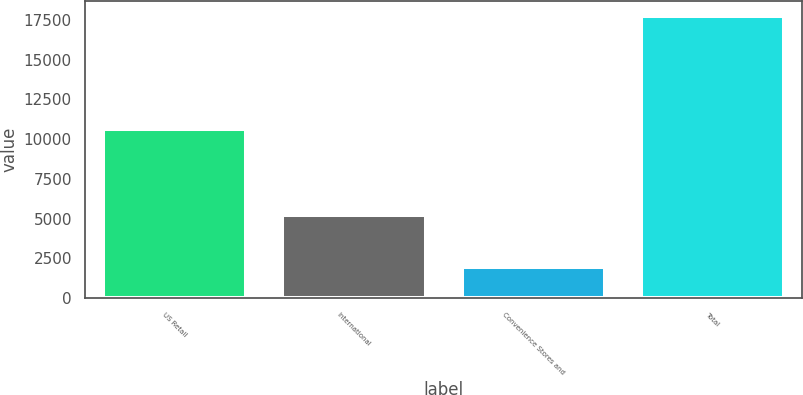Convert chart to OTSL. <chart><loc_0><loc_0><loc_500><loc_500><bar_chart><fcel>US Retail<fcel>International<fcel>Convenience Stores and<fcel>Total<nl><fcel>10614.9<fcel>5200.2<fcel>1959<fcel>17774.1<nl></chart> 